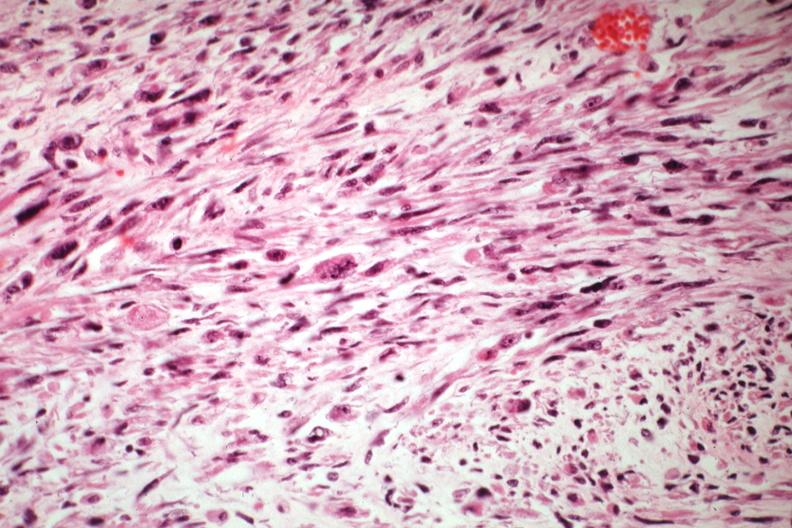s mixed mesodermal tumor present?
Answer the question using a single word or phrase. Yes 